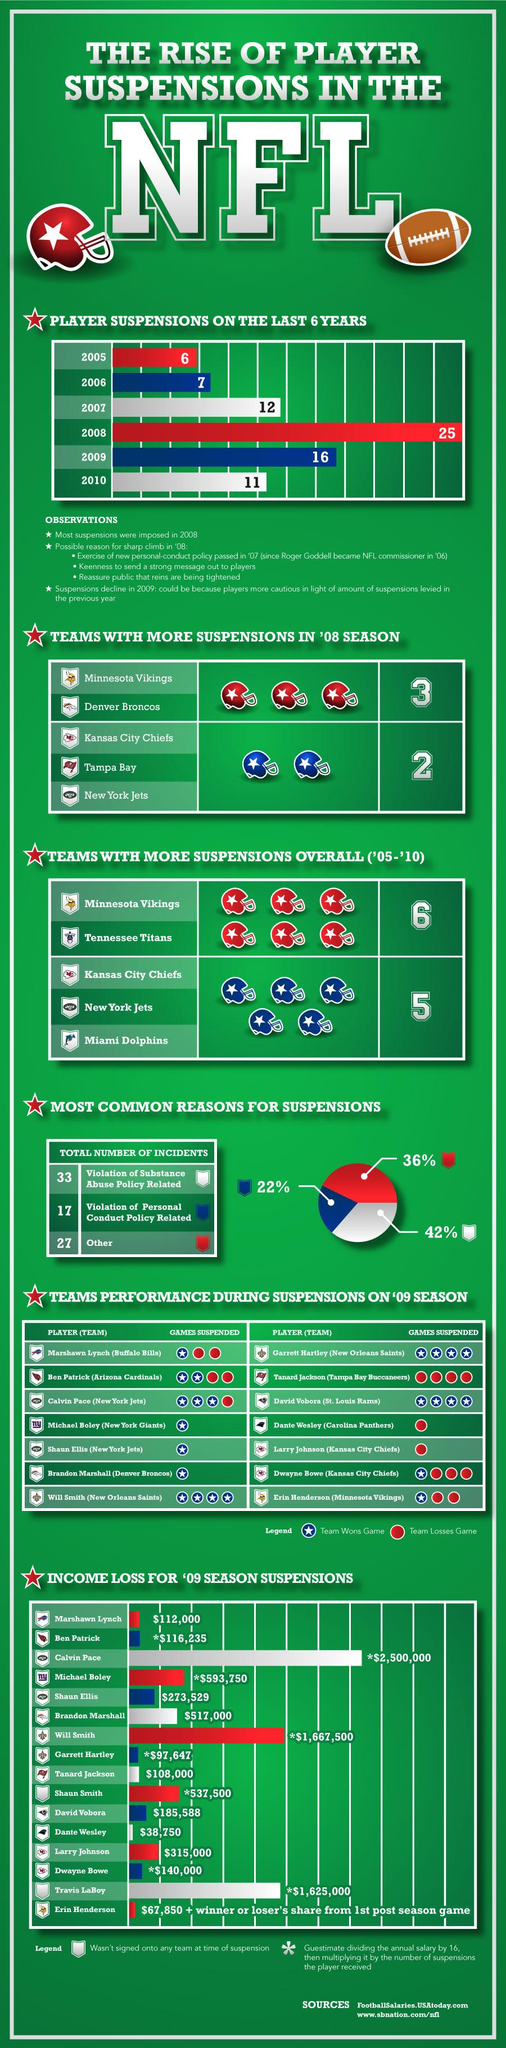Highlight a few significant elements in this photo. The total income loss for Dante Wesley and Marshawn Lynch is $150,750. In the 2008 season, the Kansas City Chiefs, Tampa Bay, and New York Jets each had two suspensions. The Minnesota Vikings and the Tennessee Titans had more than five suspensions between the years 2005 and 2010. According to the data, 22% of the suspension was a result of a violation of the personal conduct policy. During the years 2008 and 2009, the suspension duration exceeded 15 days. 